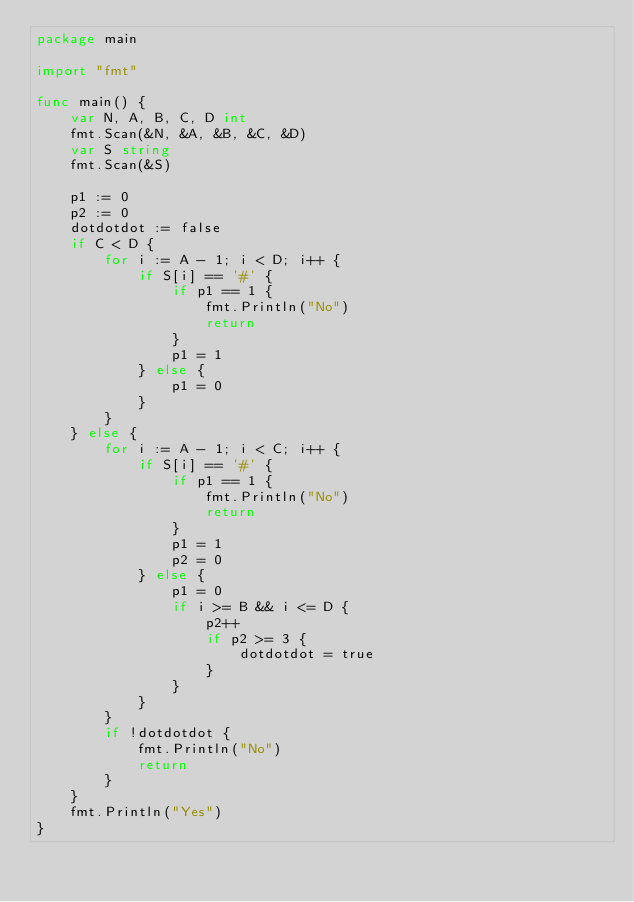<code> <loc_0><loc_0><loc_500><loc_500><_Go_>package main

import "fmt"

func main() {
	var N, A, B, C, D int
	fmt.Scan(&N, &A, &B, &C, &D)
	var S string
	fmt.Scan(&S)

	p1 := 0
	p2 := 0
	dotdotdot := false
	if C < D {
		for i := A - 1; i < D; i++ {
			if S[i] == '#' {
				if p1 == 1 {
					fmt.Println("No")
					return
				}
				p1 = 1
			} else {
				p1 = 0
			}
		}
	} else {
		for i := A - 1; i < C; i++ {
			if S[i] == '#' {
				if p1 == 1 {
					fmt.Println("No")
					return
				}
				p1 = 1
				p2 = 0
			} else {
				p1 = 0
				if i >= B && i <= D {
					p2++
					if p2 >= 3 {
						dotdotdot = true
					}
				}
			}
		}
		if !dotdotdot {
			fmt.Println("No")
			return
		}
	}
	fmt.Println("Yes")
}
</code> 